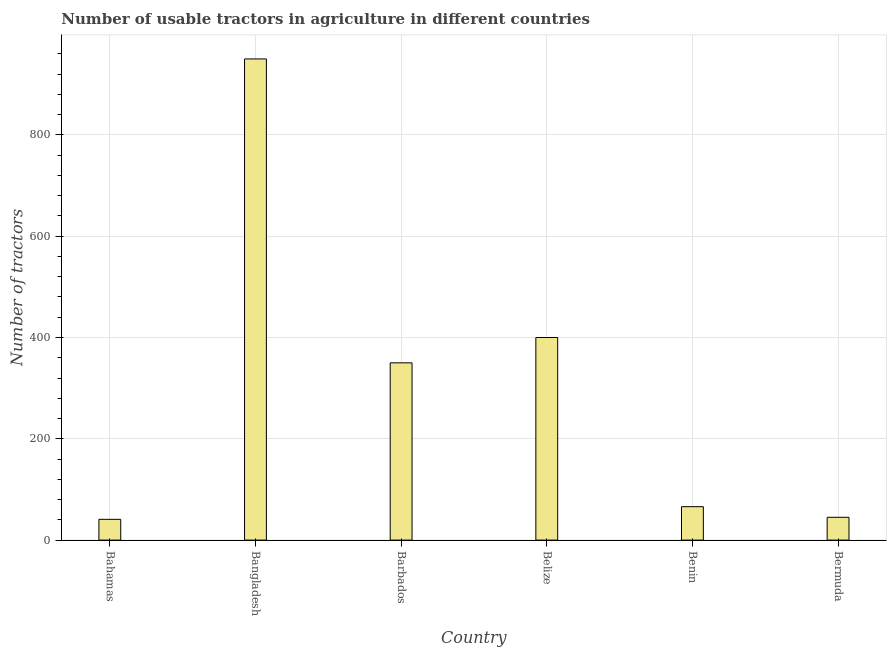What is the title of the graph?
Your answer should be compact. Number of usable tractors in agriculture in different countries. What is the label or title of the Y-axis?
Make the answer very short. Number of tractors. Across all countries, what is the maximum number of tractors?
Provide a succinct answer. 950. Across all countries, what is the minimum number of tractors?
Provide a succinct answer. 41. In which country was the number of tractors maximum?
Your answer should be compact. Bangladesh. In which country was the number of tractors minimum?
Your answer should be very brief. Bahamas. What is the sum of the number of tractors?
Offer a terse response. 1852. What is the difference between the number of tractors in Bangladesh and Belize?
Provide a succinct answer. 550. What is the average number of tractors per country?
Your answer should be compact. 308. What is the median number of tractors?
Your answer should be compact. 208. What is the ratio of the number of tractors in Barbados to that in Bermuda?
Offer a very short reply. 7.78. Is the number of tractors in Bahamas less than that in Barbados?
Give a very brief answer. Yes. Is the difference between the number of tractors in Bangladesh and Benin greater than the difference between any two countries?
Offer a very short reply. No. What is the difference between the highest and the second highest number of tractors?
Provide a short and direct response. 550. Is the sum of the number of tractors in Bahamas and Benin greater than the maximum number of tractors across all countries?
Provide a short and direct response. No. What is the difference between the highest and the lowest number of tractors?
Provide a short and direct response. 909. In how many countries, is the number of tractors greater than the average number of tractors taken over all countries?
Provide a short and direct response. 3. Are all the bars in the graph horizontal?
Your response must be concise. No. What is the difference between two consecutive major ticks on the Y-axis?
Provide a short and direct response. 200. What is the Number of tractors of Bahamas?
Your answer should be compact. 41. What is the Number of tractors in Bangladesh?
Your answer should be very brief. 950. What is the Number of tractors of Barbados?
Make the answer very short. 350. What is the Number of tractors in Belize?
Provide a short and direct response. 400. What is the Number of tractors in Benin?
Keep it short and to the point. 66. What is the difference between the Number of tractors in Bahamas and Bangladesh?
Your response must be concise. -909. What is the difference between the Number of tractors in Bahamas and Barbados?
Keep it short and to the point. -309. What is the difference between the Number of tractors in Bahamas and Belize?
Give a very brief answer. -359. What is the difference between the Number of tractors in Bahamas and Benin?
Provide a succinct answer. -25. What is the difference between the Number of tractors in Bangladesh and Barbados?
Provide a succinct answer. 600. What is the difference between the Number of tractors in Bangladesh and Belize?
Make the answer very short. 550. What is the difference between the Number of tractors in Bangladesh and Benin?
Make the answer very short. 884. What is the difference between the Number of tractors in Bangladesh and Bermuda?
Keep it short and to the point. 905. What is the difference between the Number of tractors in Barbados and Belize?
Your response must be concise. -50. What is the difference between the Number of tractors in Barbados and Benin?
Provide a short and direct response. 284. What is the difference between the Number of tractors in Barbados and Bermuda?
Make the answer very short. 305. What is the difference between the Number of tractors in Belize and Benin?
Offer a terse response. 334. What is the difference between the Number of tractors in Belize and Bermuda?
Give a very brief answer. 355. What is the difference between the Number of tractors in Benin and Bermuda?
Keep it short and to the point. 21. What is the ratio of the Number of tractors in Bahamas to that in Bangladesh?
Give a very brief answer. 0.04. What is the ratio of the Number of tractors in Bahamas to that in Barbados?
Provide a short and direct response. 0.12. What is the ratio of the Number of tractors in Bahamas to that in Belize?
Your response must be concise. 0.1. What is the ratio of the Number of tractors in Bahamas to that in Benin?
Keep it short and to the point. 0.62. What is the ratio of the Number of tractors in Bahamas to that in Bermuda?
Offer a terse response. 0.91. What is the ratio of the Number of tractors in Bangladesh to that in Barbados?
Offer a terse response. 2.71. What is the ratio of the Number of tractors in Bangladesh to that in Belize?
Your answer should be compact. 2.38. What is the ratio of the Number of tractors in Bangladesh to that in Benin?
Keep it short and to the point. 14.39. What is the ratio of the Number of tractors in Bangladesh to that in Bermuda?
Ensure brevity in your answer.  21.11. What is the ratio of the Number of tractors in Barbados to that in Belize?
Provide a succinct answer. 0.88. What is the ratio of the Number of tractors in Barbados to that in Benin?
Your answer should be very brief. 5.3. What is the ratio of the Number of tractors in Barbados to that in Bermuda?
Your response must be concise. 7.78. What is the ratio of the Number of tractors in Belize to that in Benin?
Your answer should be very brief. 6.06. What is the ratio of the Number of tractors in Belize to that in Bermuda?
Your answer should be compact. 8.89. What is the ratio of the Number of tractors in Benin to that in Bermuda?
Ensure brevity in your answer.  1.47. 